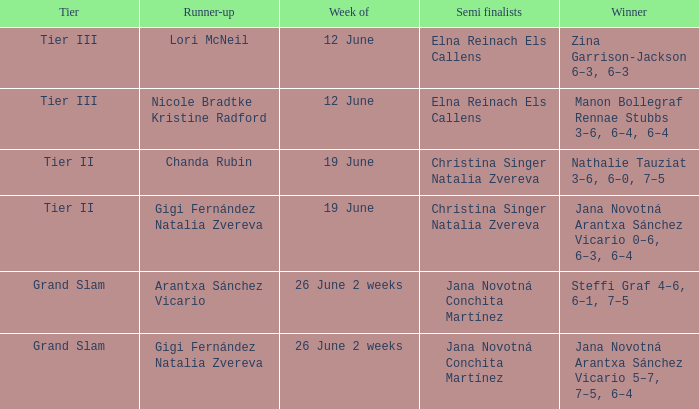In which week is the winner listed as Jana Novotná Arantxa Sánchez Vicario 5–7, 7–5, 6–4? 26 June 2 weeks. 